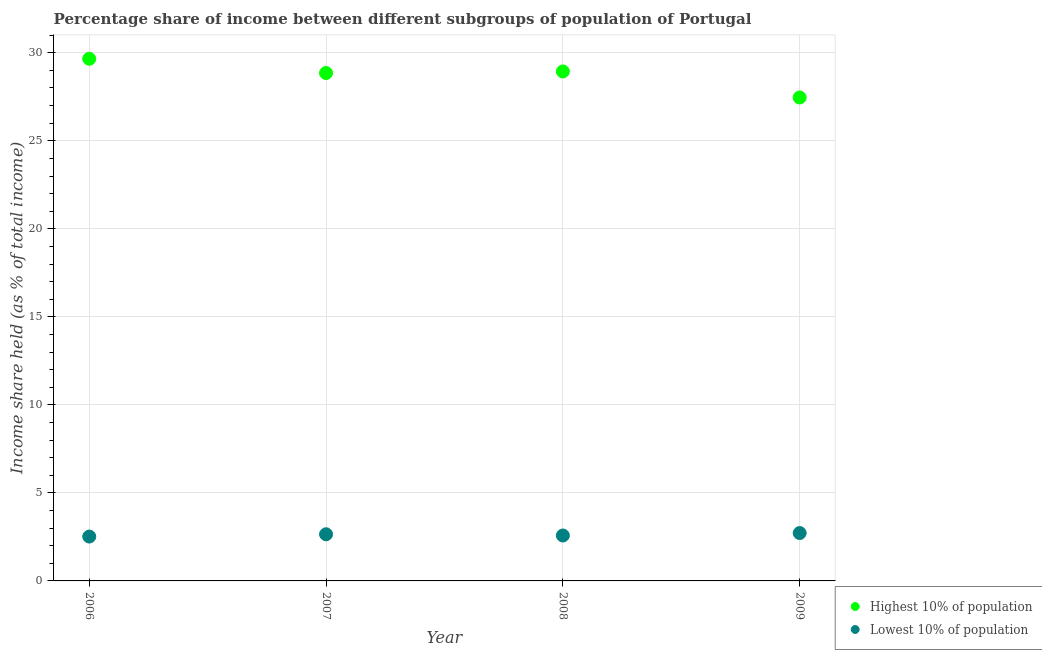How many different coloured dotlines are there?
Offer a terse response. 2. What is the income share held by highest 10% of the population in 2007?
Make the answer very short. 28.85. Across all years, what is the maximum income share held by lowest 10% of the population?
Your answer should be very brief. 2.72. Across all years, what is the minimum income share held by highest 10% of the population?
Offer a very short reply. 27.46. In which year was the income share held by highest 10% of the population maximum?
Provide a succinct answer. 2006. In which year was the income share held by highest 10% of the population minimum?
Keep it short and to the point. 2009. What is the total income share held by lowest 10% of the population in the graph?
Keep it short and to the point. 10.47. What is the difference between the income share held by lowest 10% of the population in 2006 and that in 2007?
Your answer should be compact. -0.13. What is the difference between the income share held by lowest 10% of the population in 2006 and the income share held by highest 10% of the population in 2009?
Offer a very short reply. -24.94. What is the average income share held by highest 10% of the population per year?
Ensure brevity in your answer.  28.73. In the year 2006, what is the difference between the income share held by highest 10% of the population and income share held by lowest 10% of the population?
Your answer should be compact. 27.14. In how many years, is the income share held by highest 10% of the population greater than 10 %?
Make the answer very short. 4. What is the ratio of the income share held by highest 10% of the population in 2006 to that in 2008?
Provide a short and direct response. 1.02. Is the income share held by highest 10% of the population in 2006 less than that in 2008?
Offer a terse response. No. Is the difference between the income share held by highest 10% of the population in 2006 and 2008 greater than the difference between the income share held by lowest 10% of the population in 2006 and 2008?
Provide a short and direct response. Yes. What is the difference between the highest and the second highest income share held by highest 10% of the population?
Ensure brevity in your answer.  0.72. What is the difference between the highest and the lowest income share held by lowest 10% of the population?
Offer a terse response. 0.2. In how many years, is the income share held by lowest 10% of the population greater than the average income share held by lowest 10% of the population taken over all years?
Offer a very short reply. 2. Does the income share held by lowest 10% of the population monotonically increase over the years?
Provide a short and direct response. No. Is the income share held by highest 10% of the population strictly less than the income share held by lowest 10% of the population over the years?
Offer a very short reply. No. How many dotlines are there?
Provide a succinct answer. 2. What is the difference between two consecutive major ticks on the Y-axis?
Offer a terse response. 5. What is the title of the graph?
Your response must be concise. Percentage share of income between different subgroups of population of Portugal. Does "Electricity and heat production" appear as one of the legend labels in the graph?
Your response must be concise. No. What is the label or title of the Y-axis?
Make the answer very short. Income share held (as % of total income). What is the Income share held (as % of total income) in Highest 10% of population in 2006?
Your answer should be compact. 29.66. What is the Income share held (as % of total income) in Lowest 10% of population in 2006?
Provide a short and direct response. 2.52. What is the Income share held (as % of total income) in Highest 10% of population in 2007?
Provide a succinct answer. 28.85. What is the Income share held (as % of total income) of Lowest 10% of population in 2007?
Provide a short and direct response. 2.65. What is the Income share held (as % of total income) of Highest 10% of population in 2008?
Offer a terse response. 28.94. What is the Income share held (as % of total income) of Lowest 10% of population in 2008?
Make the answer very short. 2.58. What is the Income share held (as % of total income) of Highest 10% of population in 2009?
Give a very brief answer. 27.46. What is the Income share held (as % of total income) of Lowest 10% of population in 2009?
Offer a terse response. 2.72. Across all years, what is the maximum Income share held (as % of total income) of Highest 10% of population?
Offer a very short reply. 29.66. Across all years, what is the maximum Income share held (as % of total income) in Lowest 10% of population?
Offer a very short reply. 2.72. Across all years, what is the minimum Income share held (as % of total income) in Highest 10% of population?
Offer a very short reply. 27.46. Across all years, what is the minimum Income share held (as % of total income) in Lowest 10% of population?
Your answer should be very brief. 2.52. What is the total Income share held (as % of total income) of Highest 10% of population in the graph?
Keep it short and to the point. 114.91. What is the total Income share held (as % of total income) in Lowest 10% of population in the graph?
Give a very brief answer. 10.47. What is the difference between the Income share held (as % of total income) of Highest 10% of population in 2006 and that in 2007?
Make the answer very short. 0.81. What is the difference between the Income share held (as % of total income) in Lowest 10% of population in 2006 and that in 2007?
Your answer should be very brief. -0.13. What is the difference between the Income share held (as % of total income) of Highest 10% of population in 2006 and that in 2008?
Your response must be concise. 0.72. What is the difference between the Income share held (as % of total income) of Lowest 10% of population in 2006 and that in 2008?
Make the answer very short. -0.06. What is the difference between the Income share held (as % of total income) of Lowest 10% of population in 2006 and that in 2009?
Give a very brief answer. -0.2. What is the difference between the Income share held (as % of total income) of Highest 10% of population in 2007 and that in 2008?
Make the answer very short. -0.09. What is the difference between the Income share held (as % of total income) in Lowest 10% of population in 2007 and that in 2008?
Ensure brevity in your answer.  0.07. What is the difference between the Income share held (as % of total income) in Highest 10% of population in 2007 and that in 2009?
Provide a succinct answer. 1.39. What is the difference between the Income share held (as % of total income) in Lowest 10% of population in 2007 and that in 2009?
Your answer should be very brief. -0.07. What is the difference between the Income share held (as % of total income) of Highest 10% of population in 2008 and that in 2009?
Provide a short and direct response. 1.48. What is the difference between the Income share held (as % of total income) of Lowest 10% of population in 2008 and that in 2009?
Ensure brevity in your answer.  -0.14. What is the difference between the Income share held (as % of total income) of Highest 10% of population in 2006 and the Income share held (as % of total income) of Lowest 10% of population in 2007?
Offer a terse response. 27.01. What is the difference between the Income share held (as % of total income) in Highest 10% of population in 2006 and the Income share held (as % of total income) in Lowest 10% of population in 2008?
Keep it short and to the point. 27.08. What is the difference between the Income share held (as % of total income) of Highest 10% of population in 2006 and the Income share held (as % of total income) of Lowest 10% of population in 2009?
Give a very brief answer. 26.94. What is the difference between the Income share held (as % of total income) in Highest 10% of population in 2007 and the Income share held (as % of total income) in Lowest 10% of population in 2008?
Provide a short and direct response. 26.27. What is the difference between the Income share held (as % of total income) in Highest 10% of population in 2007 and the Income share held (as % of total income) in Lowest 10% of population in 2009?
Provide a succinct answer. 26.13. What is the difference between the Income share held (as % of total income) in Highest 10% of population in 2008 and the Income share held (as % of total income) in Lowest 10% of population in 2009?
Give a very brief answer. 26.22. What is the average Income share held (as % of total income) of Highest 10% of population per year?
Provide a short and direct response. 28.73. What is the average Income share held (as % of total income) in Lowest 10% of population per year?
Your answer should be compact. 2.62. In the year 2006, what is the difference between the Income share held (as % of total income) of Highest 10% of population and Income share held (as % of total income) of Lowest 10% of population?
Provide a short and direct response. 27.14. In the year 2007, what is the difference between the Income share held (as % of total income) of Highest 10% of population and Income share held (as % of total income) of Lowest 10% of population?
Ensure brevity in your answer.  26.2. In the year 2008, what is the difference between the Income share held (as % of total income) in Highest 10% of population and Income share held (as % of total income) in Lowest 10% of population?
Your response must be concise. 26.36. In the year 2009, what is the difference between the Income share held (as % of total income) in Highest 10% of population and Income share held (as % of total income) in Lowest 10% of population?
Give a very brief answer. 24.74. What is the ratio of the Income share held (as % of total income) in Highest 10% of population in 2006 to that in 2007?
Keep it short and to the point. 1.03. What is the ratio of the Income share held (as % of total income) of Lowest 10% of population in 2006 to that in 2007?
Give a very brief answer. 0.95. What is the ratio of the Income share held (as % of total income) of Highest 10% of population in 2006 to that in 2008?
Offer a very short reply. 1.02. What is the ratio of the Income share held (as % of total income) of Lowest 10% of population in 2006 to that in 2008?
Offer a very short reply. 0.98. What is the ratio of the Income share held (as % of total income) of Highest 10% of population in 2006 to that in 2009?
Offer a very short reply. 1.08. What is the ratio of the Income share held (as % of total income) of Lowest 10% of population in 2006 to that in 2009?
Ensure brevity in your answer.  0.93. What is the ratio of the Income share held (as % of total income) of Lowest 10% of population in 2007 to that in 2008?
Make the answer very short. 1.03. What is the ratio of the Income share held (as % of total income) of Highest 10% of population in 2007 to that in 2009?
Provide a succinct answer. 1.05. What is the ratio of the Income share held (as % of total income) of Lowest 10% of population in 2007 to that in 2009?
Your response must be concise. 0.97. What is the ratio of the Income share held (as % of total income) in Highest 10% of population in 2008 to that in 2009?
Your answer should be compact. 1.05. What is the ratio of the Income share held (as % of total income) in Lowest 10% of population in 2008 to that in 2009?
Your answer should be very brief. 0.95. What is the difference between the highest and the second highest Income share held (as % of total income) of Highest 10% of population?
Your answer should be compact. 0.72. What is the difference between the highest and the second highest Income share held (as % of total income) in Lowest 10% of population?
Offer a very short reply. 0.07. What is the difference between the highest and the lowest Income share held (as % of total income) of Highest 10% of population?
Your response must be concise. 2.2. What is the difference between the highest and the lowest Income share held (as % of total income) of Lowest 10% of population?
Offer a very short reply. 0.2. 